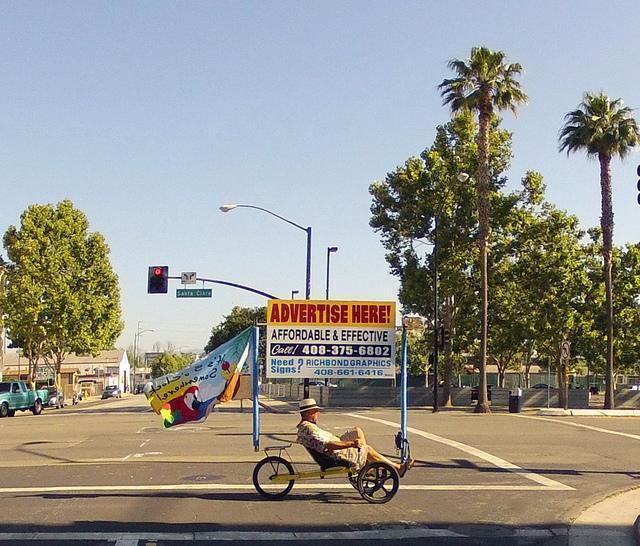How many people are in the photo?
Give a very brief answer. 1. 